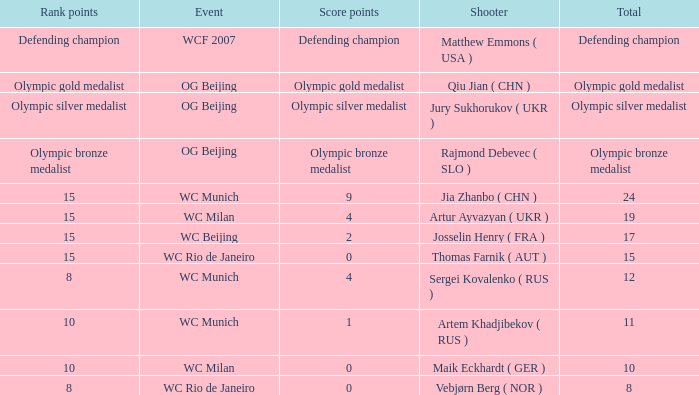Who is the shooter with 15 rank points, and 0 score points? Thomas Farnik ( AUT ). 